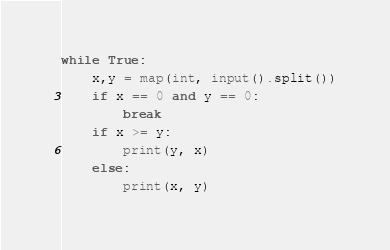Convert code to text. <code><loc_0><loc_0><loc_500><loc_500><_Python_>while True:
    x,y = map(int, input().split())
    if x == 0 and y == 0:
        break
    if x >= y:
        print(y, x)
    else:
        print(x, y)
</code> 